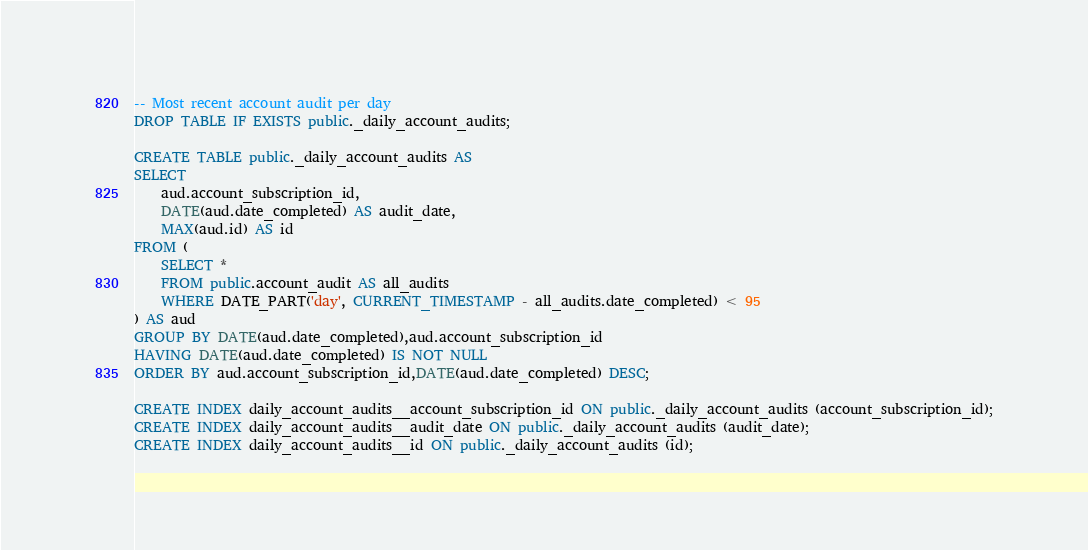<code> <loc_0><loc_0><loc_500><loc_500><_SQL_>-- Most recent account audit per day
DROP TABLE IF EXISTS public._daily_account_audits;

CREATE TABLE public._daily_account_audits AS
SELECT
    aud.account_subscription_id,
    DATE(aud.date_completed) AS audit_date,
    MAX(aud.id) AS id
FROM (
    SELECT *
    FROM public.account_audit AS all_audits
    WHERE DATE_PART('day', CURRENT_TIMESTAMP - all_audits.date_completed) < 95
) AS aud
GROUP BY DATE(aud.date_completed),aud.account_subscription_id
HAVING DATE(aud.date_completed) IS NOT NULL
ORDER BY aud.account_subscription_id,DATE(aud.date_completed) DESC;

CREATE INDEX daily_account_audits__account_subscription_id ON public._daily_account_audits (account_subscription_id);
CREATE INDEX daily_account_audits__audit_date ON public._daily_account_audits (audit_date);
CREATE INDEX daily_account_audits__id ON public._daily_account_audits (id);

</code> 